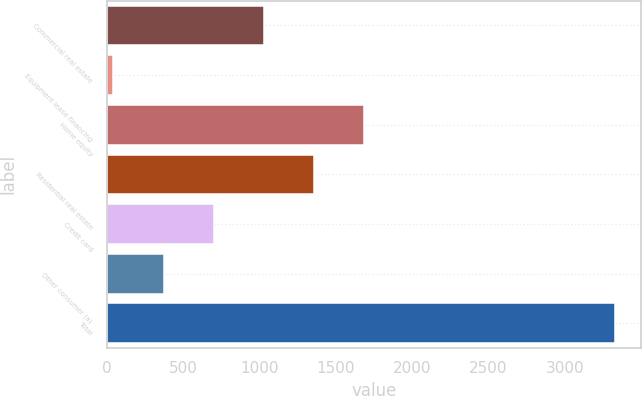Convert chart. <chart><loc_0><loc_0><loc_500><loc_500><bar_chart><fcel>Commercial real estate<fcel>Equipment lease financing<fcel>Home equity<fcel>Residential real estate<fcel>Credit card<fcel>Other consumer (a)<fcel>Total<nl><fcel>1030.1<fcel>44<fcel>1687.5<fcel>1358.8<fcel>701.4<fcel>372.7<fcel>3331<nl></chart> 